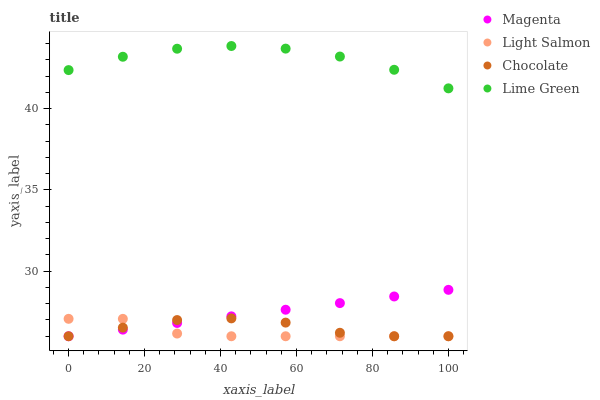Does Light Salmon have the minimum area under the curve?
Answer yes or no. Yes. Does Lime Green have the maximum area under the curve?
Answer yes or no. Yes. Does Lime Green have the minimum area under the curve?
Answer yes or no. No. Does Light Salmon have the maximum area under the curve?
Answer yes or no. No. Is Magenta the smoothest?
Answer yes or no. Yes. Is Lime Green the roughest?
Answer yes or no. Yes. Is Light Salmon the smoothest?
Answer yes or no. No. Is Light Salmon the roughest?
Answer yes or no. No. Does Magenta have the lowest value?
Answer yes or no. Yes. Does Lime Green have the lowest value?
Answer yes or no. No. Does Lime Green have the highest value?
Answer yes or no. Yes. Does Light Salmon have the highest value?
Answer yes or no. No. Is Magenta less than Lime Green?
Answer yes or no. Yes. Is Lime Green greater than Light Salmon?
Answer yes or no. Yes. Does Magenta intersect Light Salmon?
Answer yes or no. Yes. Is Magenta less than Light Salmon?
Answer yes or no. No. Is Magenta greater than Light Salmon?
Answer yes or no. No. Does Magenta intersect Lime Green?
Answer yes or no. No. 